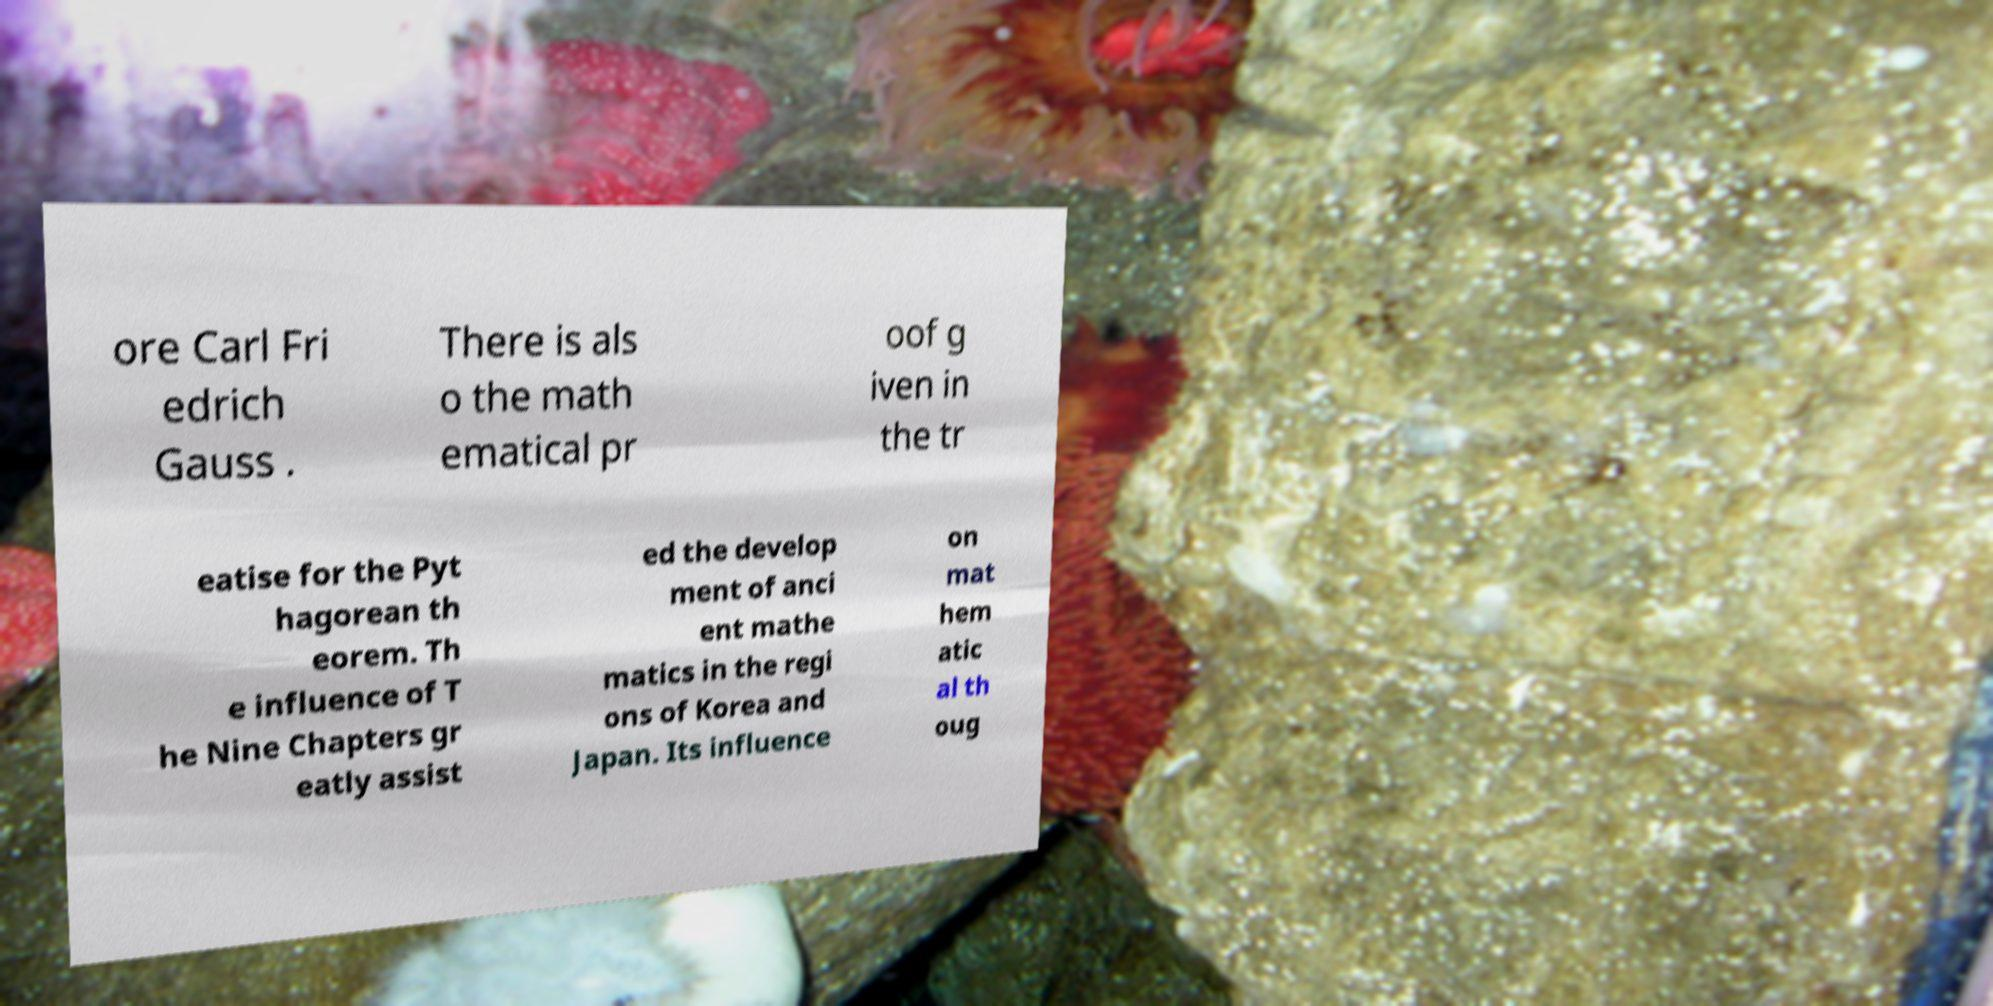There's text embedded in this image that I need extracted. Can you transcribe it verbatim? ore Carl Fri edrich Gauss . There is als o the math ematical pr oof g iven in the tr eatise for the Pyt hagorean th eorem. Th e influence of T he Nine Chapters gr eatly assist ed the develop ment of anci ent mathe matics in the regi ons of Korea and Japan. Its influence on mat hem atic al th oug 